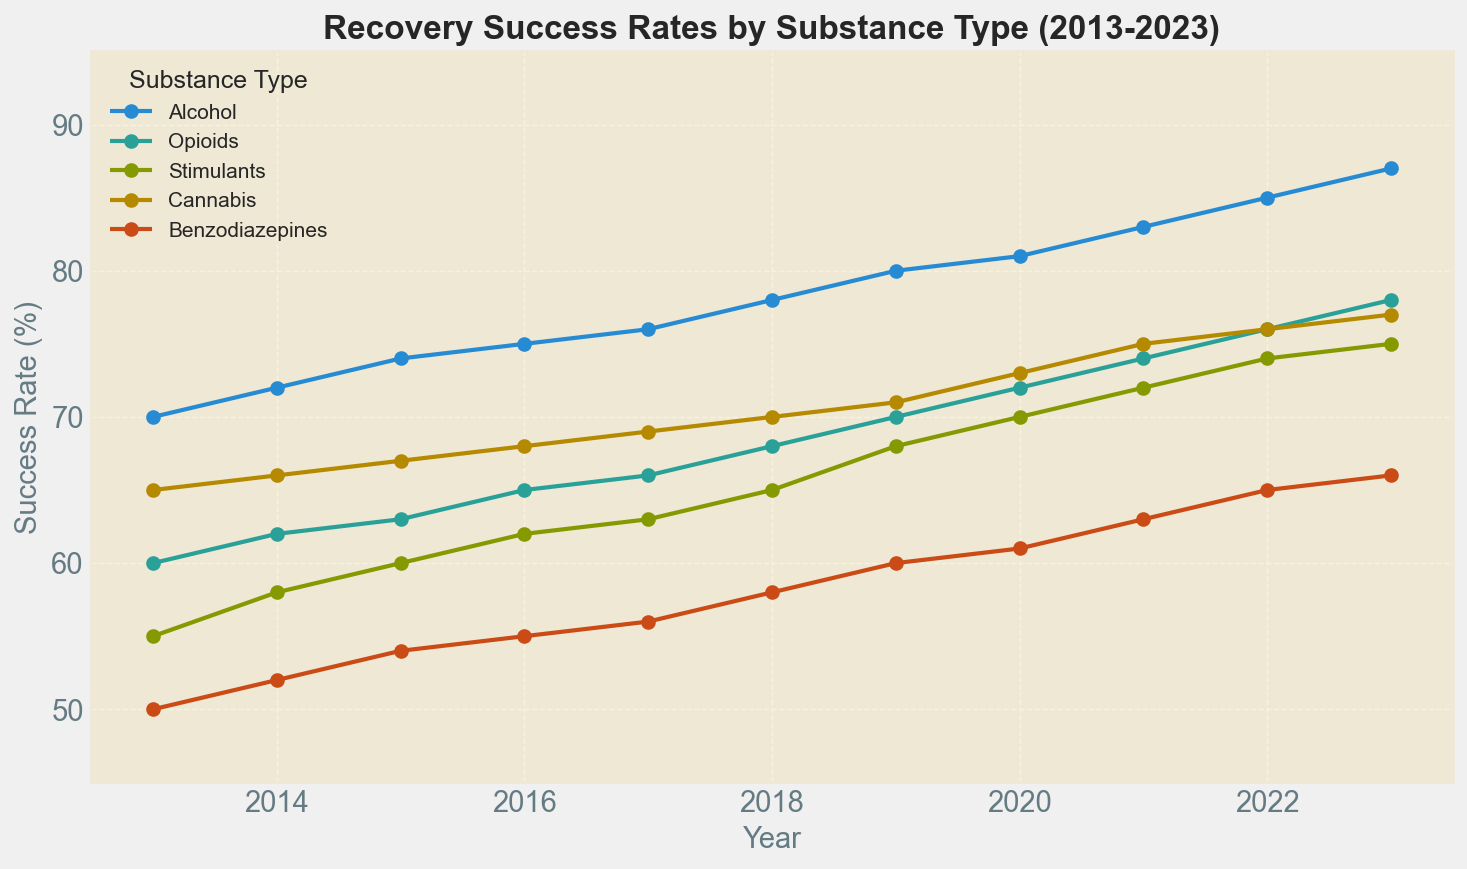What's the recovery success rate for Alcohol in 2020? Look at the line for Alcohol in the year 2020 on the horizontal axis, and read the corresponding value on the vertical axis.
Answer: 81% Which substance had the lowest recovery success rate in 2013? Compare the recovery success rates for all substances in 2013 and identify the smallest value.
Answer: Benzodiazepines How did the recovery success rate for Cannabis change from 2017 to 2019? Find the recovery success rates for Cannabis in 2017 and 2019, then calculate the difference: 71 - 69 = 2%. The rate increased by 2%.
Answer: Increased by 2% Which substance showed the greatest overall improvement in recovery success rates between 2013 and 2023? Calculate the change in success rates for each substance between 2013 and 2023 and compare them: Alcohol (87-70), Opioids (78-60), Stimulants (75-55), Cannabis (77-65), Benzodiazepines (66-50). Alcohol has the greatest improvement with an increase of 17%.
Answer: Alcohol Which year showed the biggest increase in recovery success rates for Stimulants compared to the previous year? Calculate the year-over-year increases for Stimulants and compare them. The year with the largest increase is the one with the maximum difference: 2014 (3%), 2015 (2%), 2016 (2%), 2017 (1%), 2018 (2%), 2019 (3%), 2020 (2%), 2021 (2%), 2022 (2%), 2023 (1%). The largest increase occurred between 2018 and 2019.
Answer: 2018-2019 On average, what was the recovery success rate for Benzodiazepines over the 10-year period? Sum the recovery success rates for Benzodiazepines over the 10 years and divide by 10. Calculation: (50 + 52 + 54 + 55 + 56 + 58 + 60 + 61 + 63 + 65 + 66) / 11 = 55.5%
Answer: 55.5% Which substance had the most consistent (least variable) recovery success rate trend over the 10-year period? Assess the variability of recovery success rates by observing the trends in the lines. The substance with the least fluctuation or most steady increase is Cannabis.
Answer: Cannabis In what year did the recovery success rate for Alcohol surpass 80%? Find the year where the value for Alcohol crossed 80% by looking at the line and the associated years. This happened in 2019.
Answer: 2019 By how many percentage points did the recovery success rate for Opioids increase from 2016 to 2021? Compute the difference in recovery success rates for Opioids between 2016 and 2021: 74 - 65 = 9 percentage points.
Answer: 9 percentage points 